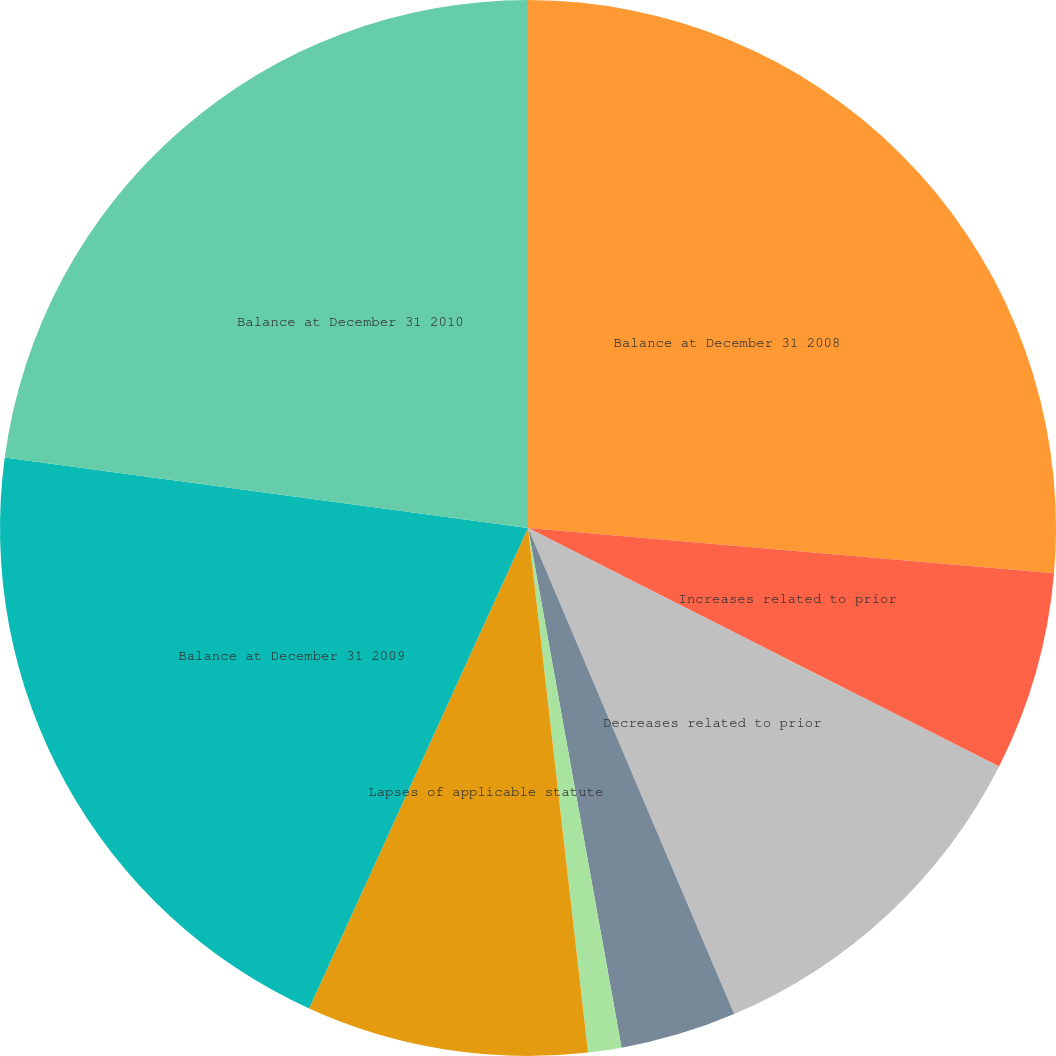Convert chart to OTSL. <chart><loc_0><loc_0><loc_500><loc_500><pie_chart><fcel>Balance at December 31 2008<fcel>Increases related to prior<fcel>Decreases related to prior<fcel>Increases related to current<fcel>Settlements during the period<fcel>Lapses of applicable statute<fcel>Balance at December 31 2009<fcel>Balance at December 31 2010<nl><fcel>26.37%<fcel>6.09%<fcel>11.16%<fcel>3.55%<fcel>1.02%<fcel>8.62%<fcel>20.33%<fcel>22.87%<nl></chart> 